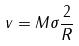Convert formula to latex. <formula><loc_0><loc_0><loc_500><loc_500>v = M \sigma \frac { 2 } { R }</formula> 